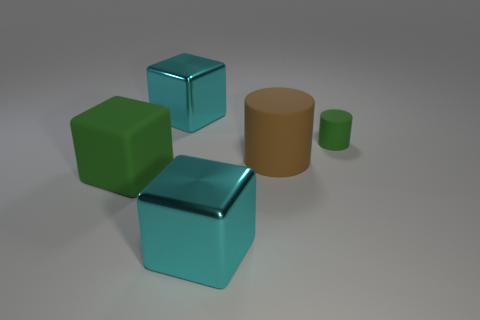Add 3 green things. How many objects exist? 8 Subtract all blocks. How many objects are left? 2 Add 3 small green rubber cylinders. How many small green rubber cylinders exist? 4 Subtract 1 brown cylinders. How many objects are left? 4 Subtract all purple spheres. Subtract all big brown matte objects. How many objects are left? 4 Add 1 small green rubber cylinders. How many small green rubber cylinders are left? 2 